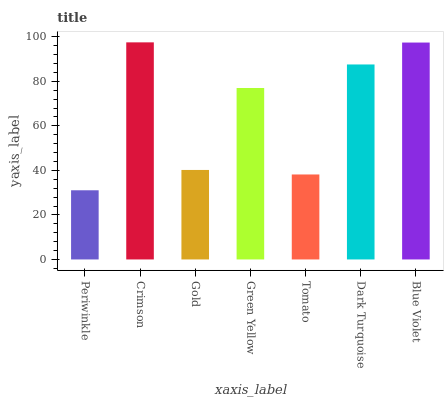Is Periwinkle the minimum?
Answer yes or no. Yes. Is Crimson the maximum?
Answer yes or no. Yes. Is Gold the minimum?
Answer yes or no. No. Is Gold the maximum?
Answer yes or no. No. Is Crimson greater than Gold?
Answer yes or no. Yes. Is Gold less than Crimson?
Answer yes or no. Yes. Is Gold greater than Crimson?
Answer yes or no. No. Is Crimson less than Gold?
Answer yes or no. No. Is Green Yellow the high median?
Answer yes or no. Yes. Is Green Yellow the low median?
Answer yes or no. Yes. Is Gold the high median?
Answer yes or no. No. Is Gold the low median?
Answer yes or no. No. 